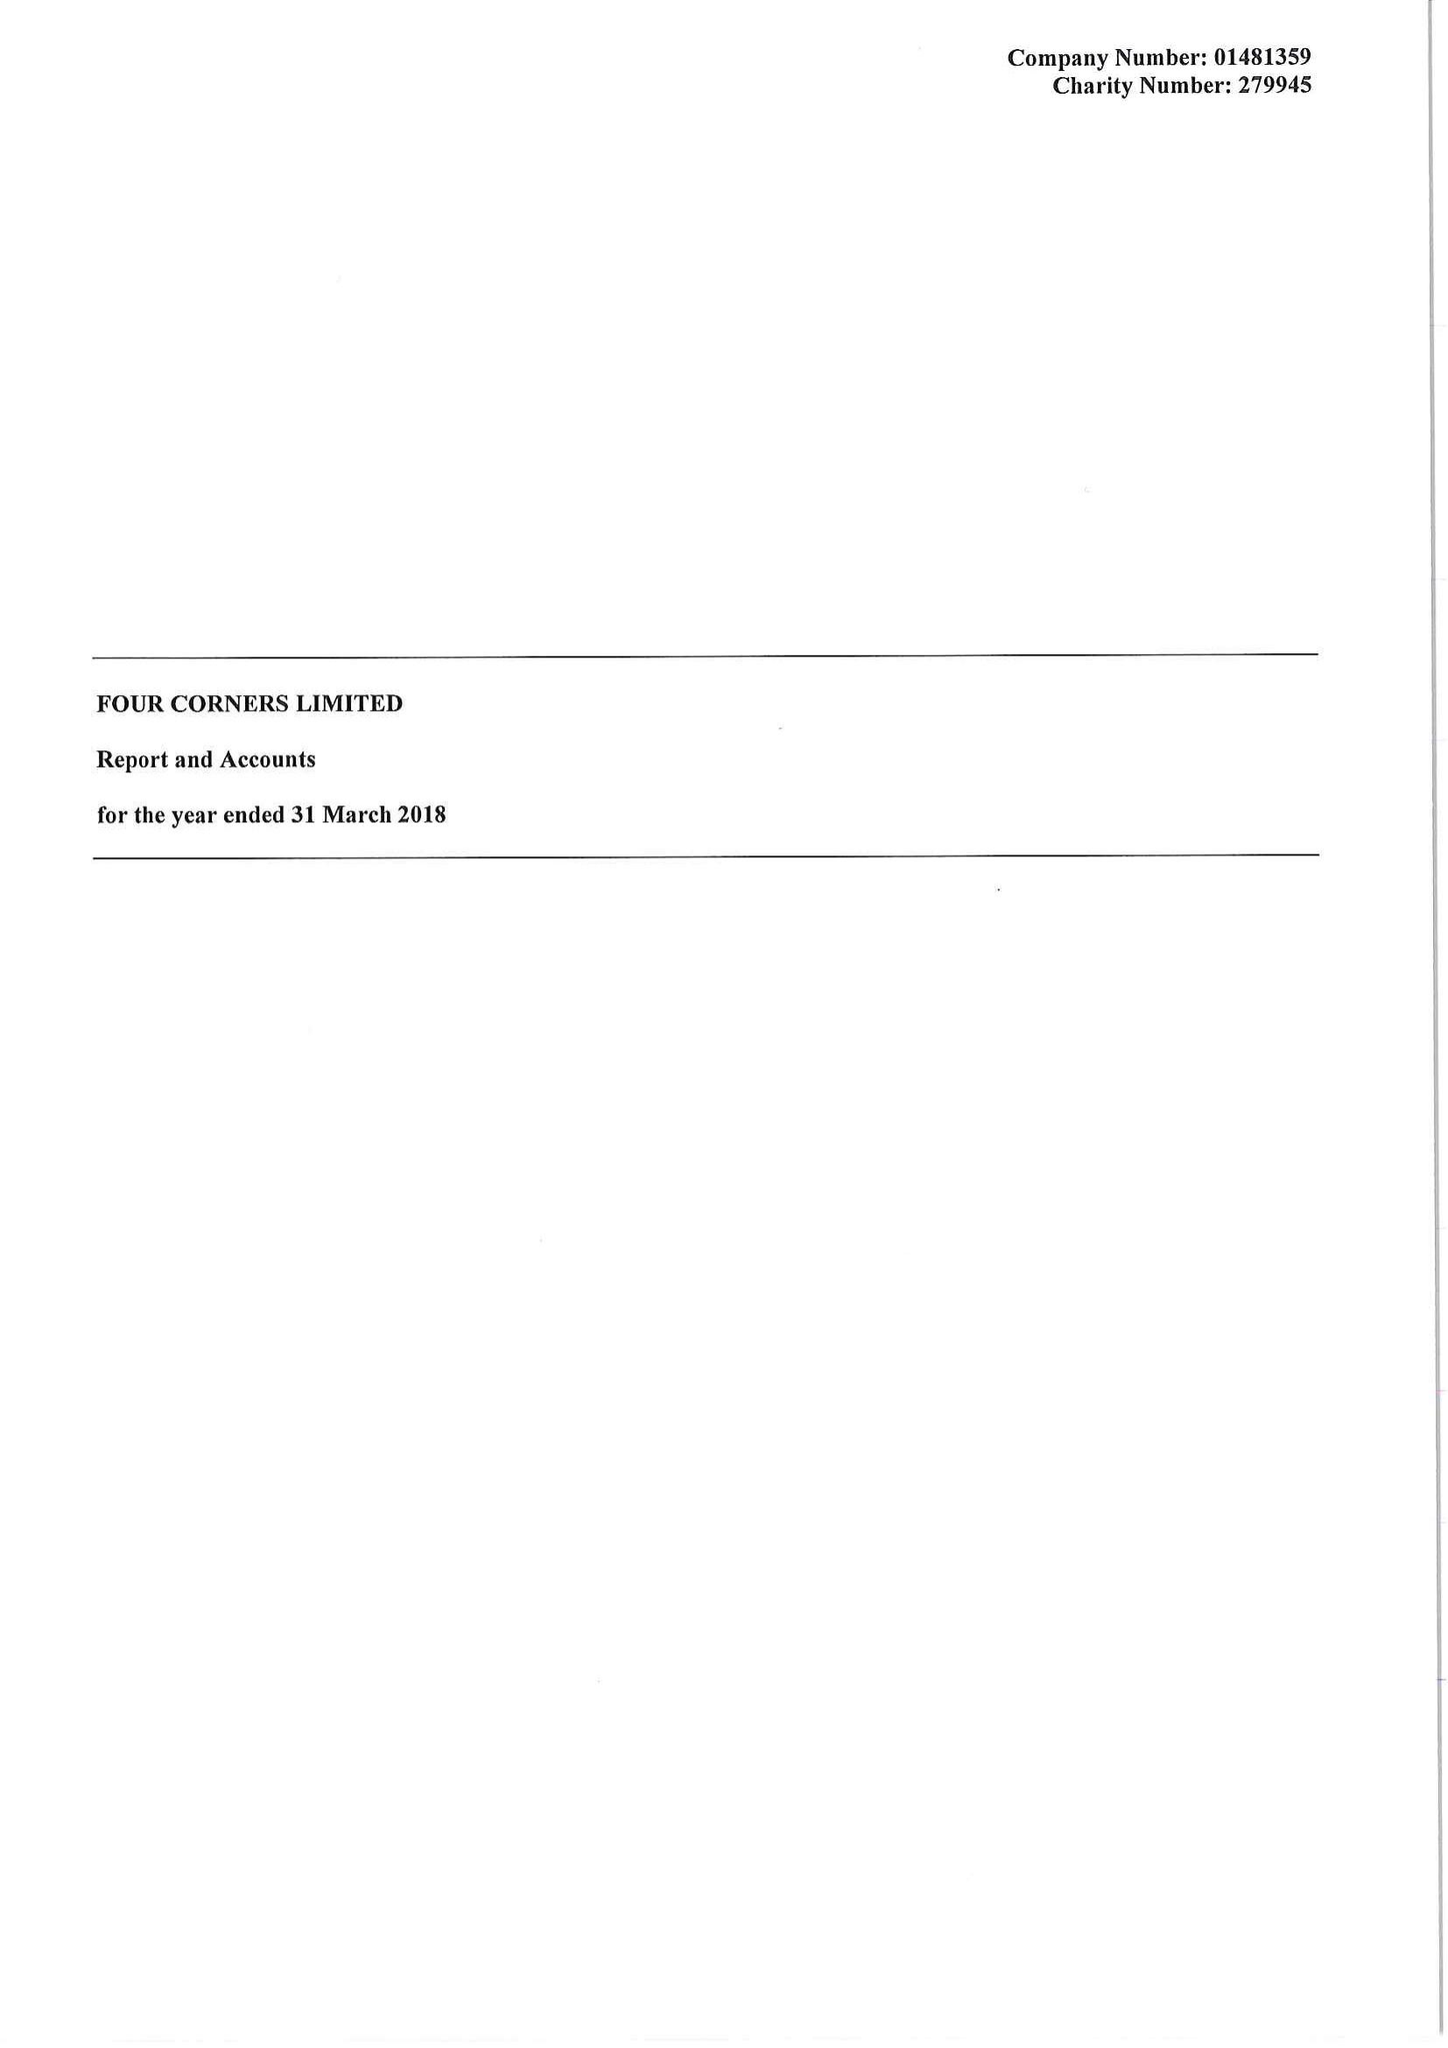What is the value for the address__post_town?
Answer the question using a single word or phrase. LONDON 